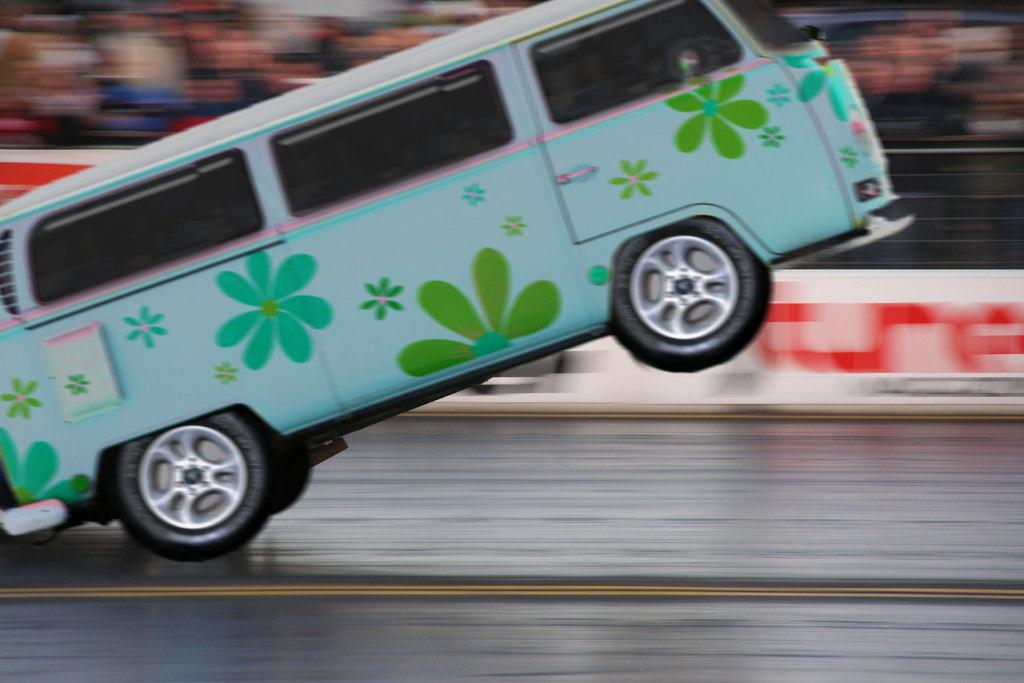What is the main subject of the image? There is a vehicle on the road in the image. What is located behind the vehicle? There is a banner behind the vehicle. What type of barrier is present in the image? There is a metal fence in the image. How would you describe the background of the image? The background of the image is blurred. What type of cabbage is being weighed on a scale in the image? There is no cabbage or scale present in the image. How many weeks does the banner in the image advertise? The image does not provide information about the duration of the banner's advertisement. 